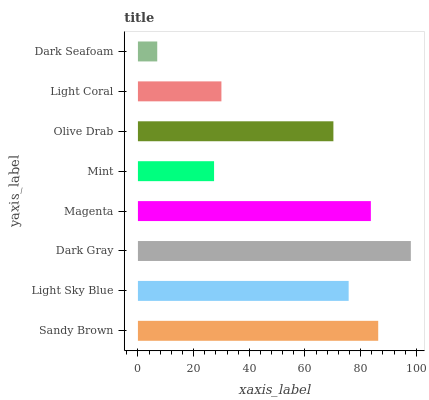Is Dark Seafoam the minimum?
Answer yes or no. Yes. Is Dark Gray the maximum?
Answer yes or no. Yes. Is Light Sky Blue the minimum?
Answer yes or no. No. Is Light Sky Blue the maximum?
Answer yes or no. No. Is Sandy Brown greater than Light Sky Blue?
Answer yes or no. Yes. Is Light Sky Blue less than Sandy Brown?
Answer yes or no. Yes. Is Light Sky Blue greater than Sandy Brown?
Answer yes or no. No. Is Sandy Brown less than Light Sky Blue?
Answer yes or no. No. Is Light Sky Blue the high median?
Answer yes or no. Yes. Is Olive Drab the low median?
Answer yes or no. Yes. Is Olive Drab the high median?
Answer yes or no. No. Is Light Coral the low median?
Answer yes or no. No. 